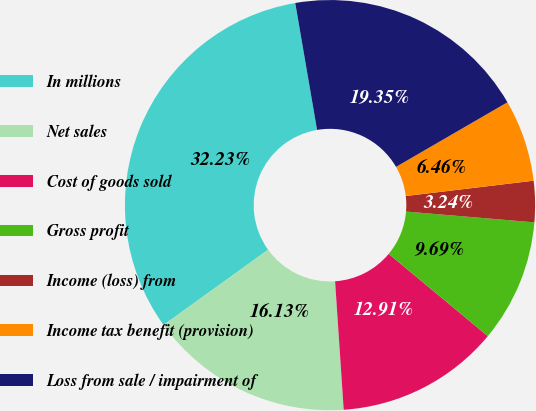Convert chart. <chart><loc_0><loc_0><loc_500><loc_500><pie_chart><fcel>In millions<fcel>Net sales<fcel>Cost of goods sold<fcel>Gross profit<fcel>Income (loss) from<fcel>Income tax benefit (provision)<fcel>Loss from sale / impairment of<nl><fcel>32.23%<fcel>16.13%<fcel>12.91%<fcel>9.69%<fcel>3.24%<fcel>6.46%<fcel>19.35%<nl></chart> 